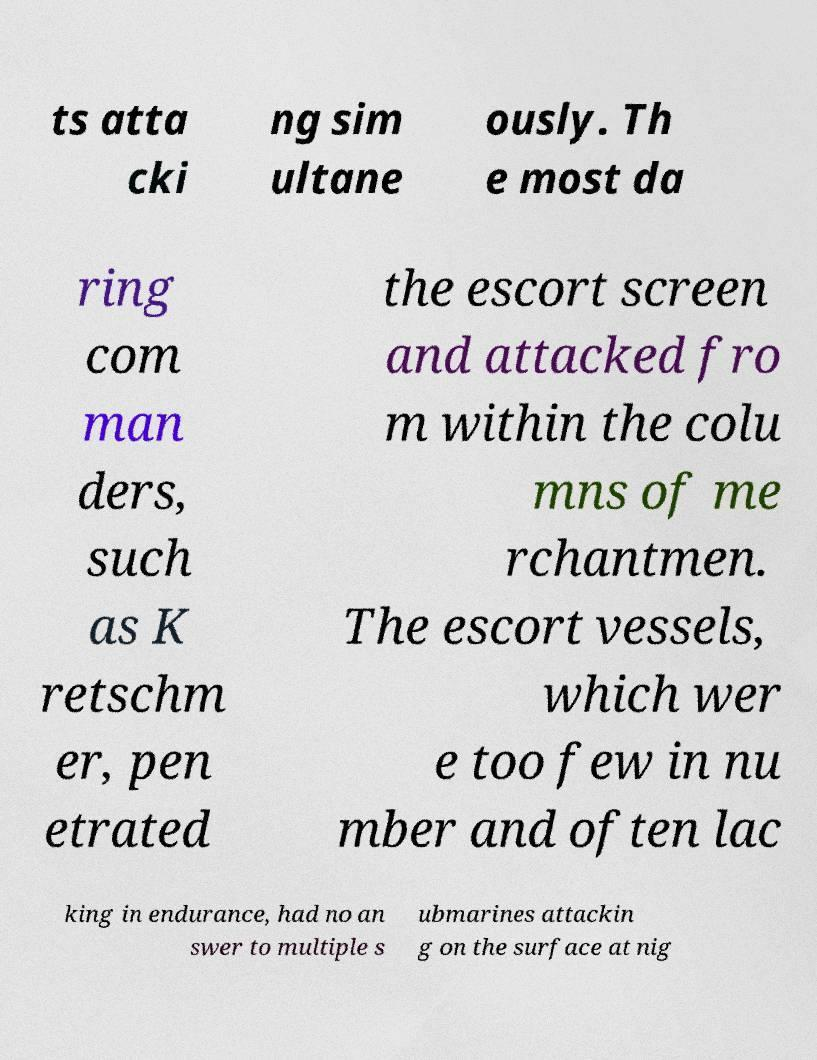Could you assist in decoding the text presented in this image and type it out clearly? ts atta cki ng sim ultane ously. Th e most da ring com man ders, such as K retschm er, pen etrated the escort screen and attacked fro m within the colu mns of me rchantmen. The escort vessels, which wer e too few in nu mber and often lac king in endurance, had no an swer to multiple s ubmarines attackin g on the surface at nig 